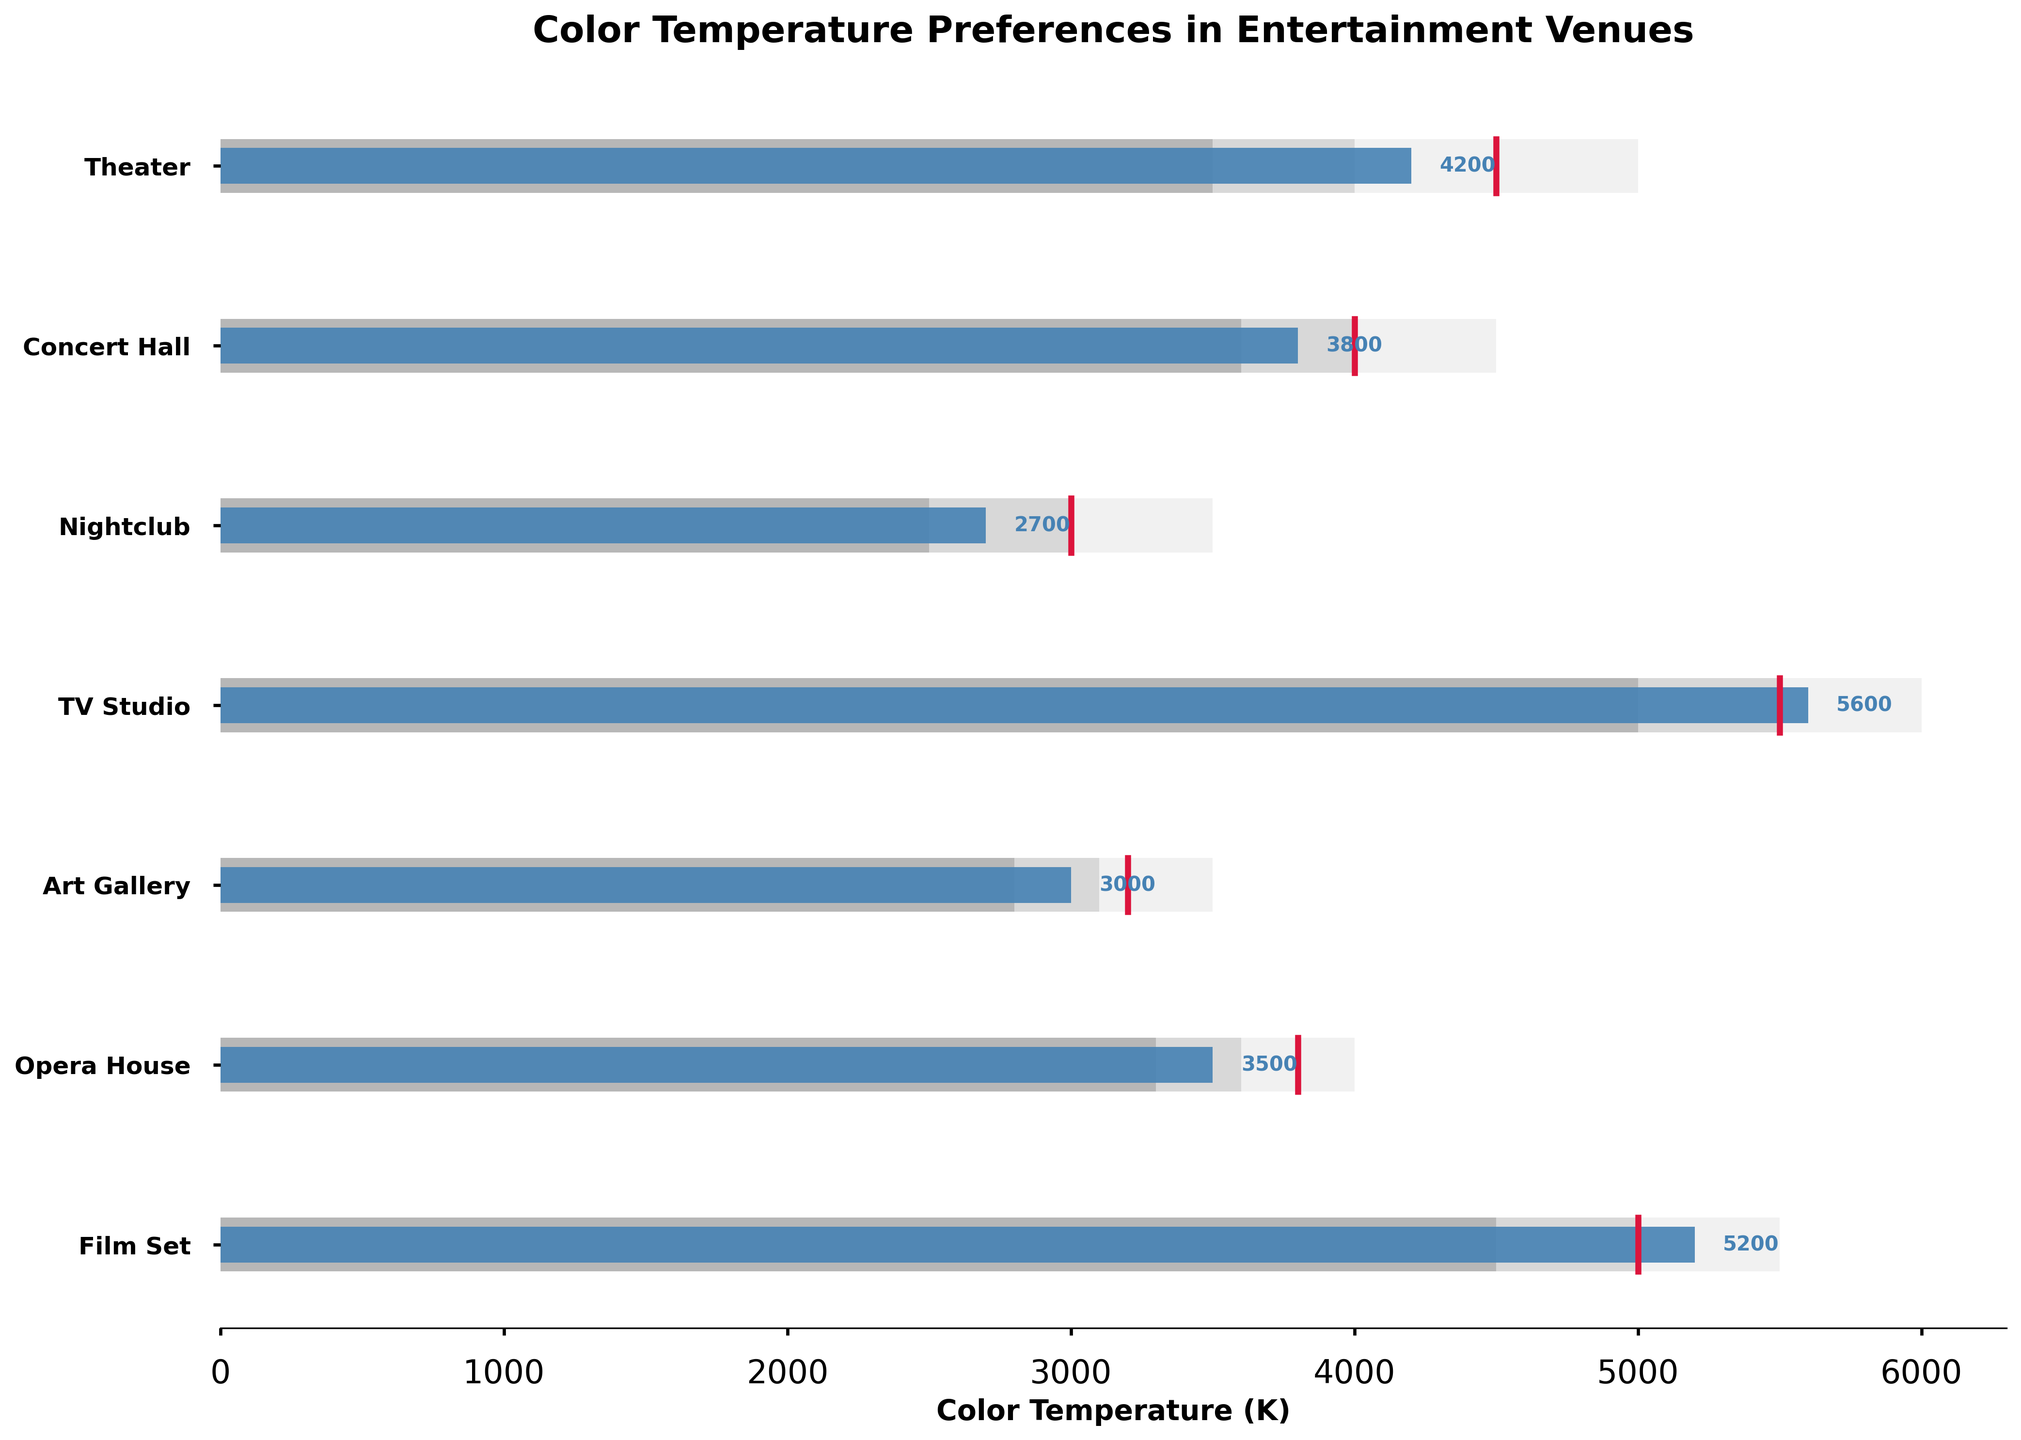What's the title of the figure? The title of the figure is always prominently displayed at the top and is designed to give an overview of what the chart represents.
Answer: Color Temperature Preferences in Entertainment Venues What is the color temperature range for TV Studios? To determine the range, look at the lowest and highest values of the bars that represent TV Studios. The ranges are 4500K to 5000K, 5000K to 5500K, and 5500K to 6000K.
Answer: 4500K to 6000K Which venue has achieved a higher actual color temperature than its target? To find the venues exceeding their target color temperature, look at where the 'Actual' bar extends beyond the 'Target' marker.
Answer: TV Studio, Film Set What's the average of the actual color temperatures across all venues? Add all the actual color temperatures and divide by the number of venues: (4200 + 3800 + 2700 + 5600 + 3000 + 3500 + 5200) / 7 = 38500 / 7.
Answer: 5500K Which venue's color temperature is closest to its target? Look for the smallest difference between the 'Actual' bar and 'Target' marker. The actual color temperature for "Concert Hall" at 3800K is closest to its target of 4000K with a difference of only 200K.
Answer: Concert Hall Are theaters within the acceptable range for color temperatures? By comparing the actual value (4200K) with the ranges (3000-3500K, 3500-4000K, 4000-5000K), we can see that the theater's actual color temperature is within the acceptable range.
Answer: Yes Which venues have a target color temperature of 5000K or higher? Check each venue’s target marker to determine if it is 5000K or higher. Only TV Studio (5500K) and Film Set (5000K) meet this criterion.
Answer: TV Studio, Film Set How much higher is the actual color temperature of the Film Set compared to the Theater? Subtract the actual color temperature of the Theater from the Film Set: 5200K - 4200K = 1000K.
Answer: 1000K What are the three different intensity colors used to show ranges in the chart? Observe the color coding used in the chart for different ranges: light grey, silver, and dark grey.
Answer: Light grey, silver, dark grey 